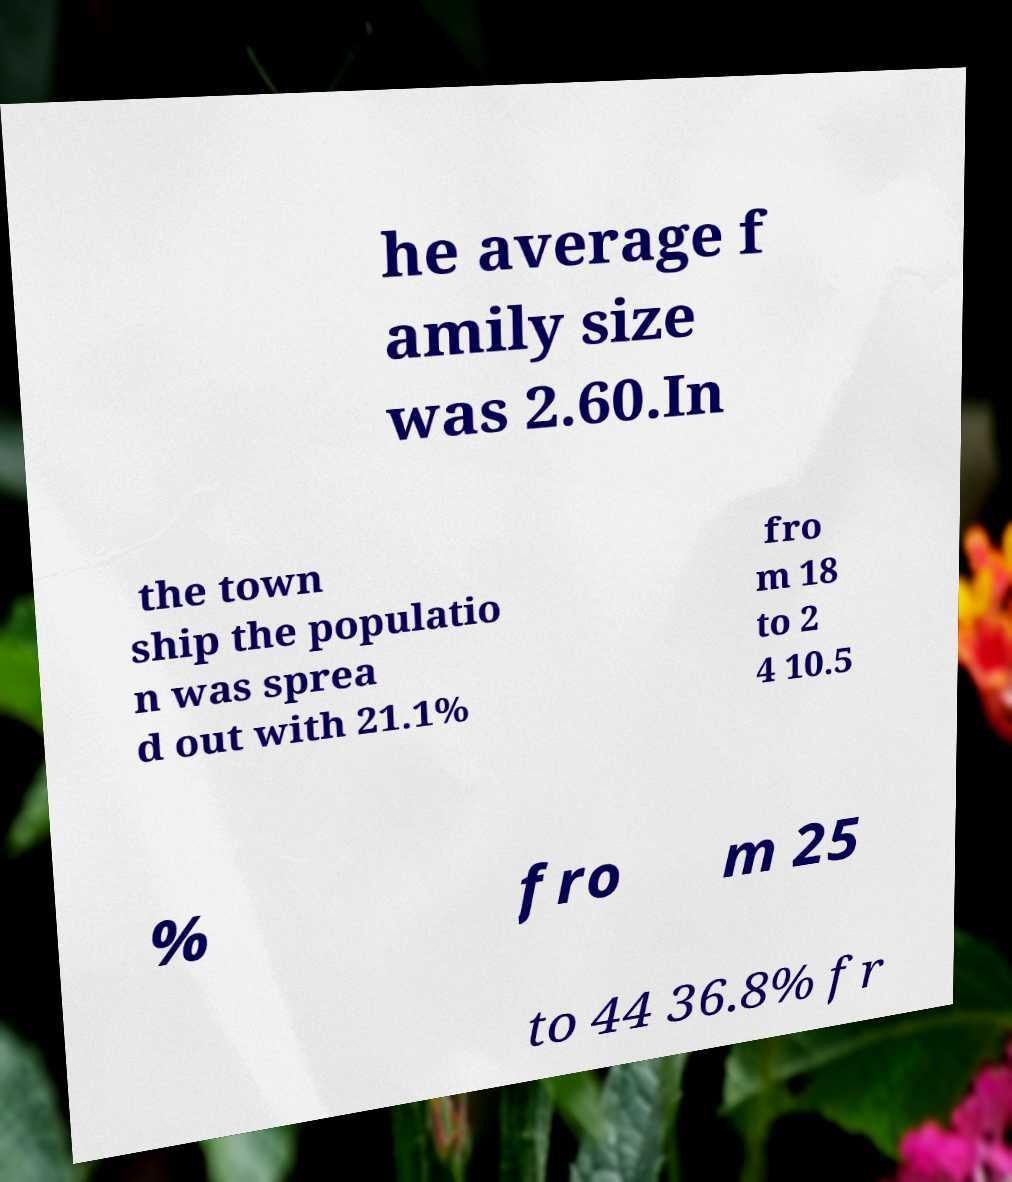For documentation purposes, I need the text within this image transcribed. Could you provide that? he average f amily size was 2.60.In the town ship the populatio n was sprea d out with 21.1% fro m 18 to 2 4 10.5 % fro m 25 to 44 36.8% fr 